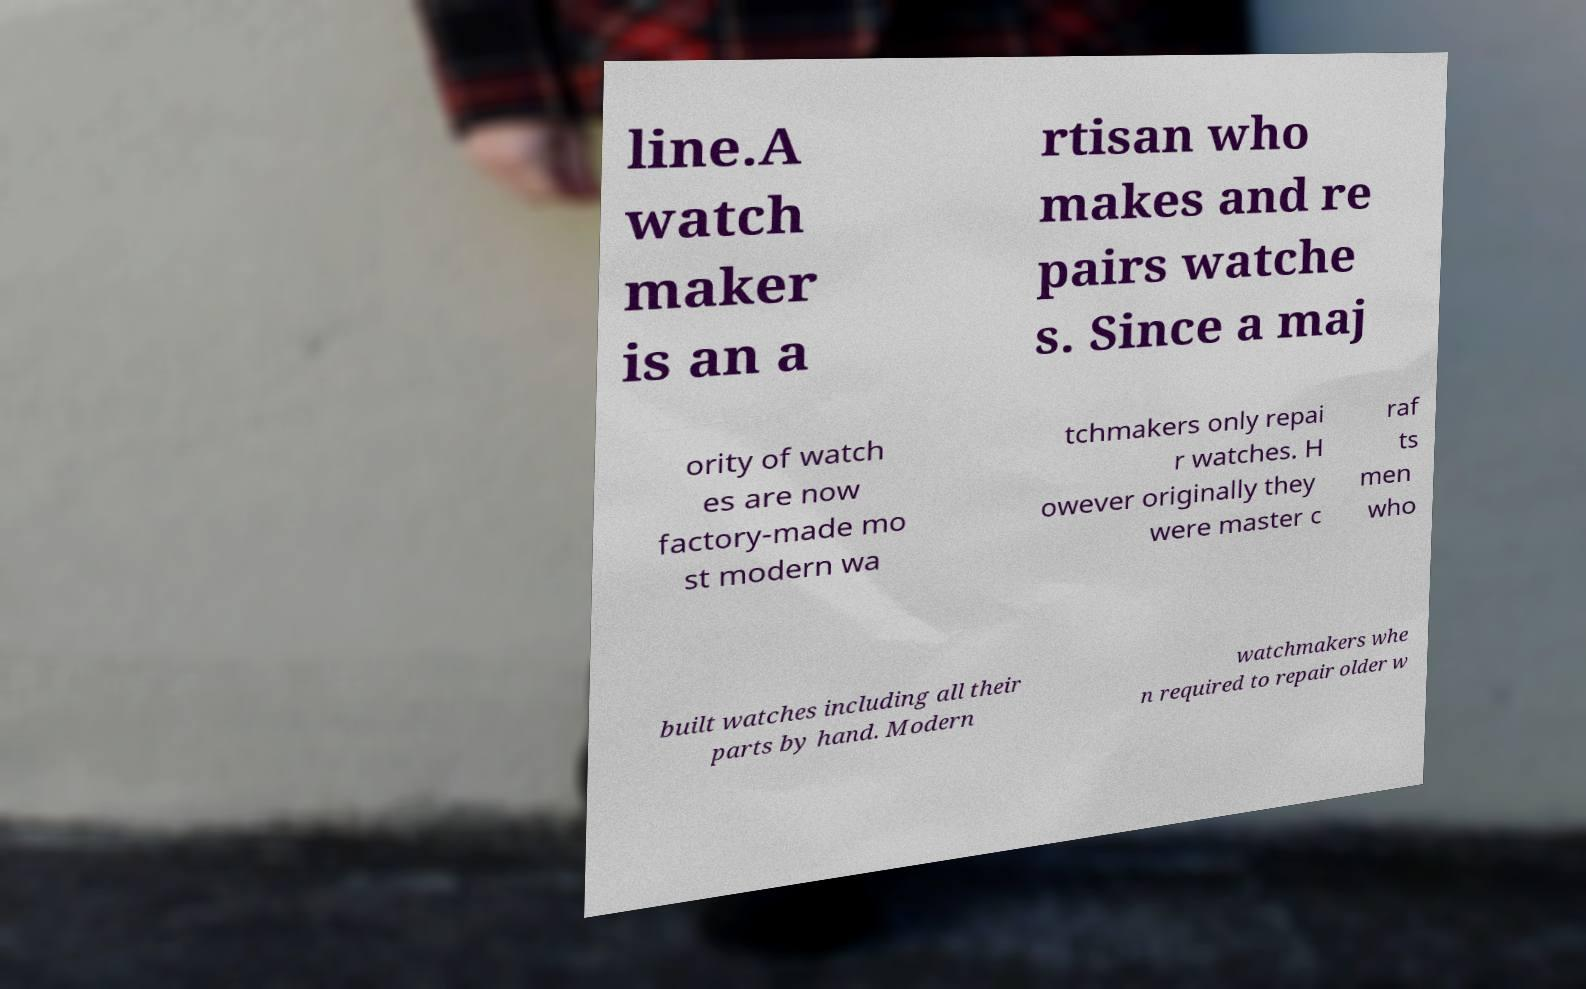Please identify and transcribe the text found in this image. line.A watch maker is an a rtisan who makes and re pairs watche s. Since a maj ority of watch es are now factory-made mo st modern wa tchmakers only repai r watches. H owever originally they were master c raf ts men who built watches including all their parts by hand. Modern watchmakers whe n required to repair older w 